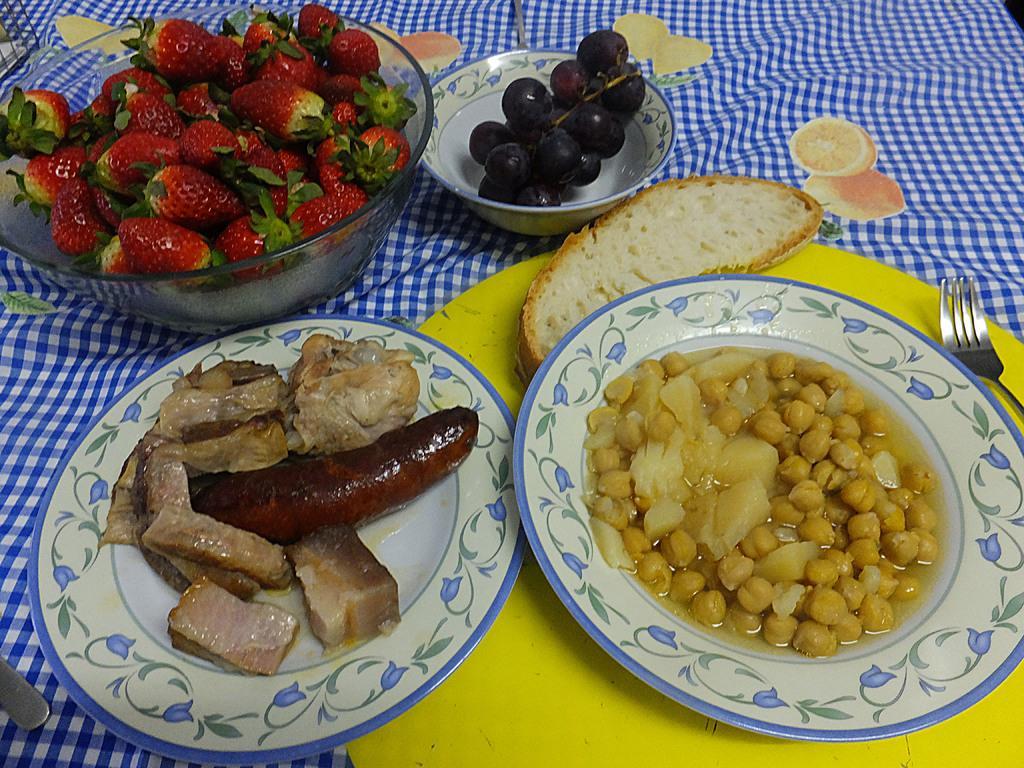Please provide a concise description of this image. This image consists of food and there is a folk and there are fruits in the bowls. 